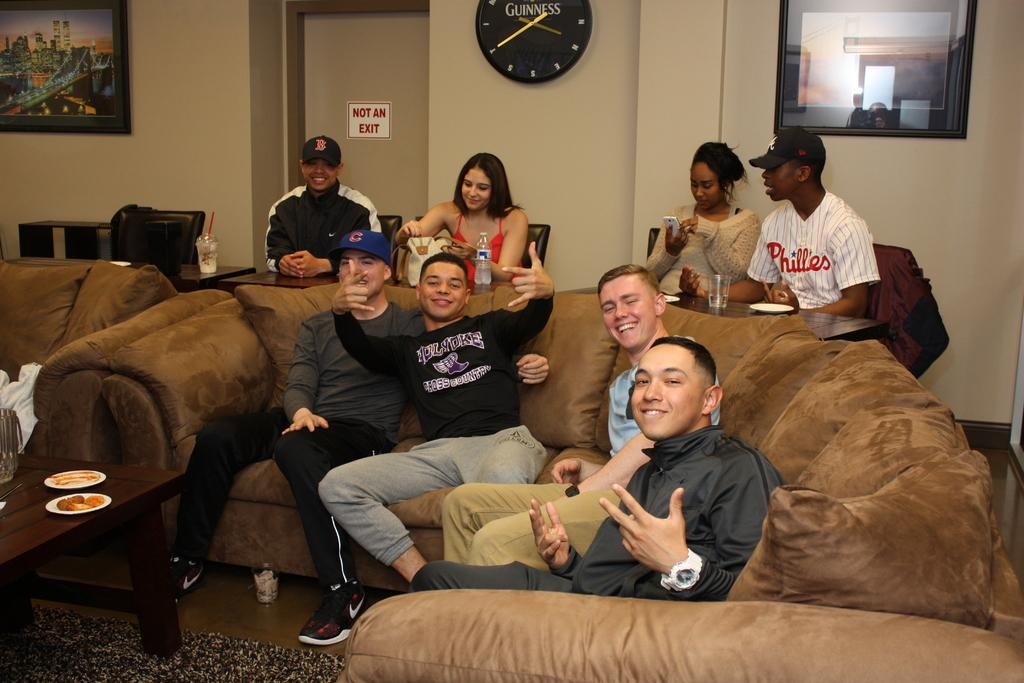<image>
Describe the image concisely. A man in a Phillies shirt sits behind a couch. 